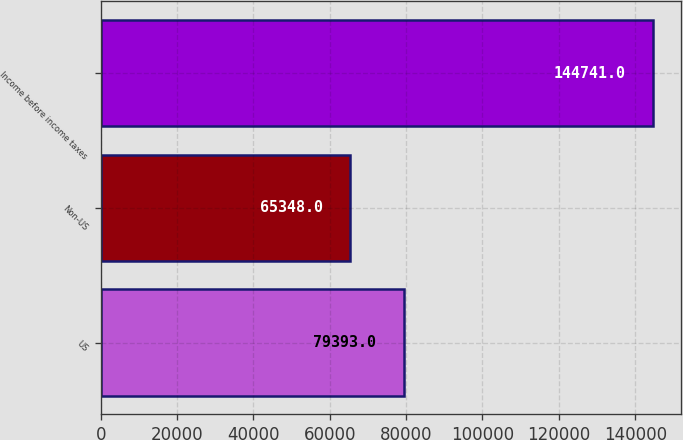<chart> <loc_0><loc_0><loc_500><loc_500><bar_chart><fcel>US<fcel>Non-US<fcel>Income before income taxes<nl><fcel>79393<fcel>65348<fcel>144741<nl></chart> 